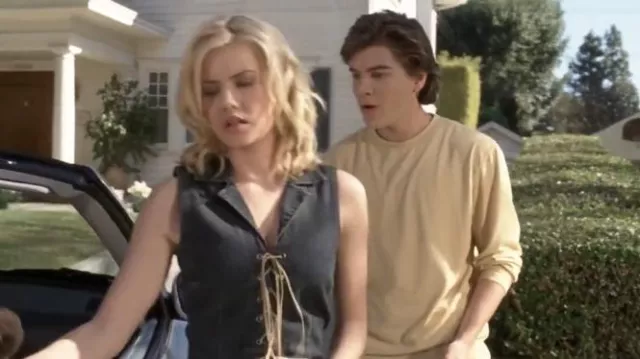What could be the possible future actions of these characters in a dramatic narrative? In a dramatic narrative, we might see the woman taking time to reflect and calm down, potentially leading to an emotional confrontation where she expresses her true feelings. This could be a turning point for their relationship, whether romantic or familial. The young man's hesitation might evolve into resolve as he decides to take action to mend their bond, perhaps by addressing the root of their conflict openly and honestly. They could have a heartfelt conversation that brings them closer together, or, if unresolved, it might lead to a significant change in their dynamic, such as a temporary or permanent separation. What if this scene was part of a comedy? How might the narrative unfold? In a comedy, this scene could take a humorous twist. Perhaps the woman is upset over a trivial misunderstanding, like a mix-up involving their car keys or a minor mishap during their trip. The young man, trying to calm her down, might inadvertently make the situation funnier with his awkward attempts to apologize or explain. Their emotional expressions could be exaggerated for comedic effect, and the scene might end with a lighthearted resolution, such as them both realizing the silliness of the situation and bursting into laughter, deciding to move forward with their journey with a renewed sense of camaraderie. What are some creative theories about the origin of their argument? A creative theory about the origin of their argument could involve a misplaced object of great importance, like a family heirloom or an envelope with critical information. Perhaps the woman found the item in the car's trunk, leading to a revelation that spurred the argument. Another theory could be that they are undercover agents whose cover was almost blown due to one of them making a crucial mistake. In a more whimsical scenario, maybe they had an argument over a magical artifact they discovered, which has unpredictable effects on their emotions and actions. The potential for storytelling is vast and varied, dependent on the characters' history and the broader world they inhabit. 